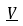Convert formula to latex. <formula><loc_0><loc_0><loc_500><loc_500>\underline { V }</formula> 